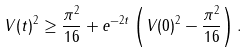Convert formula to latex. <formula><loc_0><loc_0><loc_500><loc_500>V ( t ) ^ { 2 } \geq \frac { \pi ^ { 2 } } { 1 6 } + e ^ { - 2 t } \left ( V ( 0 ) ^ { 2 } - \frac { \pi ^ { 2 } } { 1 6 } \right ) .</formula> 